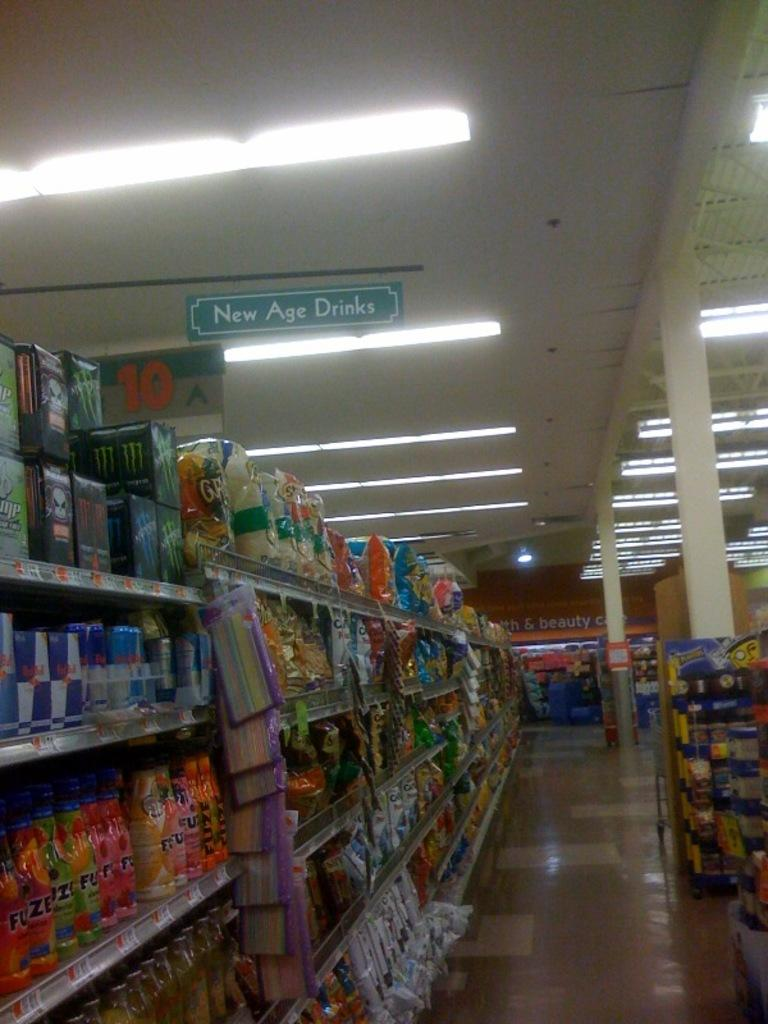<image>
Relay a brief, clear account of the picture shown. A grocery store aisle features New Age Drinks. 